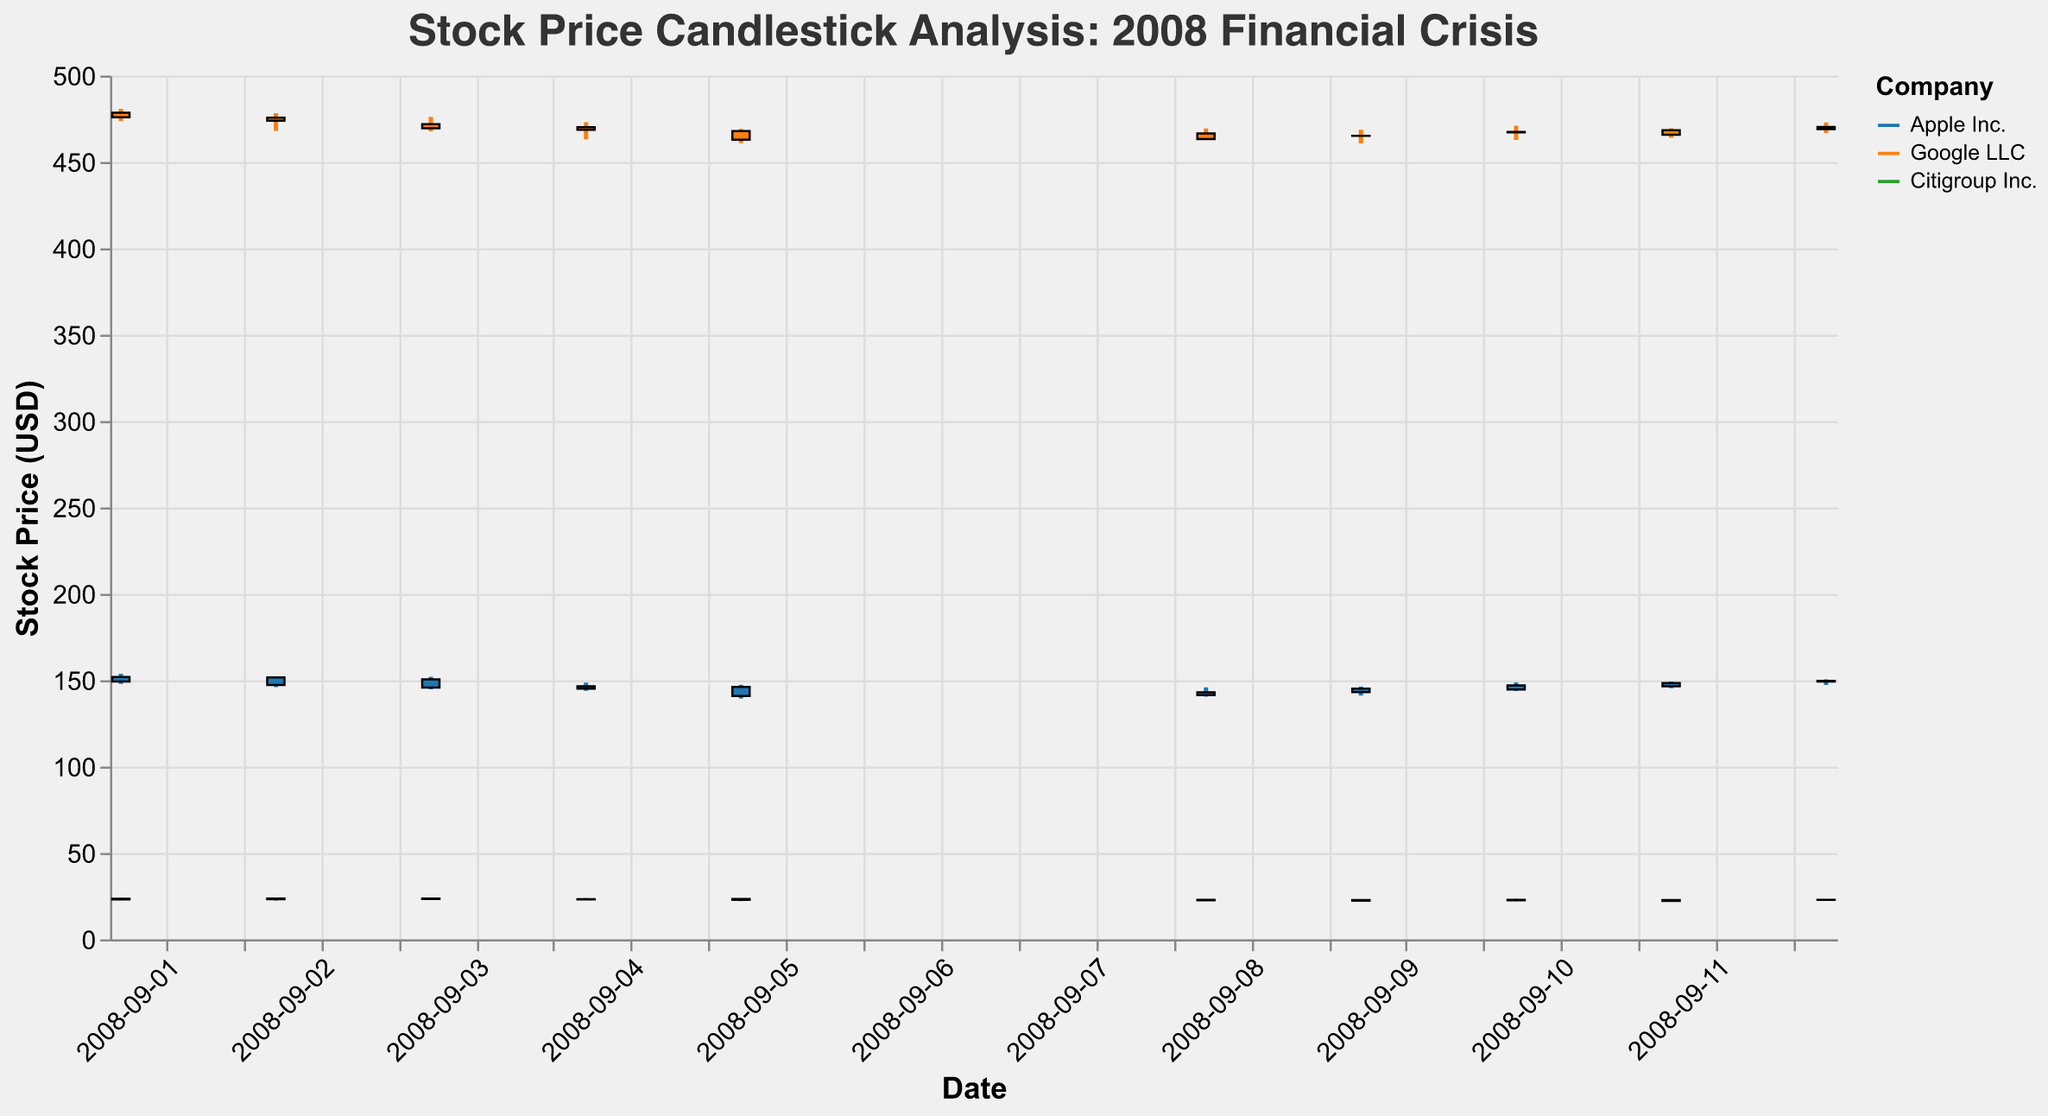What is the title of the figure? The title is usually placed at the top of the figure. It reads "Stock Price Candlestick Analysis: 2008 Financial Crisis".
Answer: Stock Price Candlestick Analysis: 2008 Financial Crisis How many companies' stock prices are shown in the figure? By observing the legend or the different colors in the plot, we can see that three companies are represented.
Answer: Three Which company had the highest opening price on September 1, 2008? Compare the opening prices for all companies on the date "2008-09-01". Apple Inc. opened at 151.93, Google LLC at 478.53, Citigroup Inc. at 23.53. Google LLC has the highest opening price among them.
Answer: Google LLC What is the trend of Apple's stock price from September 1 to September 12, 2008? Observe the sequence of Apple's closing prices from "2008-09-01" to "2008-09-12". The stock fluctuates but overall shows a moderate decline from 149.27 to 149.68, ending nearly at the same position it began.
Answer: Fluctuating with a slight decline Which company had the largest price drop between September 4 and September 5, 2008? Calculate the difference between the closing prices of September 4 and September 5 for each company:
- Apple Inc.: 146.47 - 140.91 = 5.56
- Google LLC: 468.68 - 462.91 = 5.77
- Citigroup Inc.: 23.21 - 22.89 = 0.32
Google LLC had the largest drop.
Answer: Google LLC What is the volume trend of Citigroup's shares during this period? Review the volume value for Citigroup Inc. from "2008-09-01" to "2008-09-12". The volume starts high at 237923400 and tends to decrease over the period, ending at 194568300.
Answer: Decreasing Which company experienced the lowest price on September 5, 2008, and what was it? Look at the lowest prices for each company on "2008-09-05":
- Apple Inc.: 139.39
- Google LLC: 460.87
- Citigroup Inc.: 22.09
Citigroup Inc had the lowest price.
Answer: Citigroup Inc., 22.09 Compare the closing prices of Apple Inc. on September 3 and September 4, 2008. Was there an increase or decrease, and by how much? Subtract the closing price of September 3 from that of September 4 for Apple Inc.:
146.47 - 145.73 = 0.74. The price increased.
Answer: Increase by 0.74 Between September 8 and September 9, 2008, which company had the smallest change in closing price? Calculate the differences in closing prices for each company:
- Apple Inc.: 145.09 - 142.97 = 2.12
- Google LLC: 465.15 - 466.45 = 1.30
- Citigroup Inc.: 22.79 - 22.67 = 0.12
Citigroup Inc. had the smallest change.
Answer: Citigroup Inc What is the overall trend of Google LLC's stock price during this period? Observe the sequence of Google LLC's closing prices from "2008-09-01" to "2008-09-12". The stock experiences some fluctuations but generally trends downward from 475.87 to 468.98.
Answer: Downward trend 